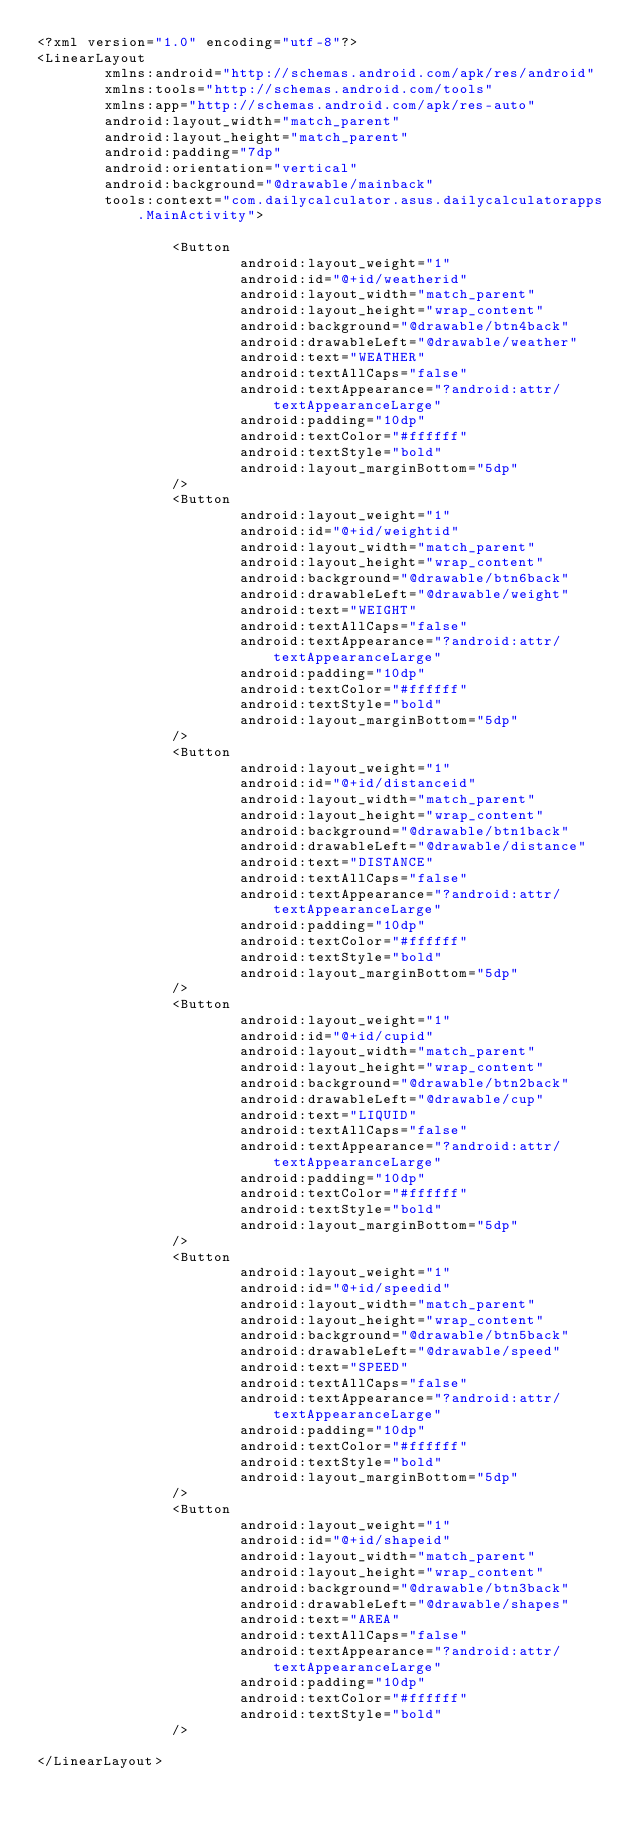<code> <loc_0><loc_0><loc_500><loc_500><_XML_><?xml version="1.0" encoding="utf-8"?>
<LinearLayout
        xmlns:android="http://schemas.android.com/apk/res/android"
        xmlns:tools="http://schemas.android.com/tools"
        xmlns:app="http://schemas.android.com/apk/res-auto"
        android:layout_width="match_parent"
        android:layout_height="match_parent"
        android:padding="7dp"
        android:orientation="vertical"
        android:background="@drawable/mainback"
        tools:context="com.dailycalculator.asus.dailycalculatorapps.MainActivity">

                <Button
                        android:layout_weight="1"
                        android:id="@+id/weatherid"
                        android:layout_width="match_parent"
                        android:layout_height="wrap_content"
                        android:background="@drawable/btn4back"
                        android:drawableLeft="@drawable/weather"
                        android:text="WEATHER"
                        android:textAllCaps="false"
                        android:textAppearance="?android:attr/textAppearanceLarge"
                        android:padding="10dp"
                        android:textColor="#ffffff"
                        android:textStyle="bold"
                        android:layout_marginBottom="5dp"
                />
                <Button
                        android:layout_weight="1"
                        android:id="@+id/weightid"
                        android:layout_width="match_parent"
                        android:layout_height="wrap_content"
                        android:background="@drawable/btn6back"
                        android:drawableLeft="@drawable/weight"
                        android:text="WEIGHT"
                        android:textAllCaps="false"
                        android:textAppearance="?android:attr/textAppearanceLarge"
                        android:padding="10dp"
                        android:textColor="#ffffff"
                        android:textStyle="bold"
                        android:layout_marginBottom="5dp"
                />
                <Button
                        android:layout_weight="1"
                        android:id="@+id/distanceid"
                        android:layout_width="match_parent"
                        android:layout_height="wrap_content"
                        android:background="@drawable/btn1back"
                        android:drawableLeft="@drawable/distance"
                        android:text="DISTANCE"
                        android:textAllCaps="false"
                        android:textAppearance="?android:attr/textAppearanceLarge"
                        android:padding="10dp"
                        android:textColor="#ffffff"
                        android:textStyle="bold"
                        android:layout_marginBottom="5dp"
                />
                <Button
                        android:layout_weight="1"
                        android:id="@+id/cupid"
                        android:layout_width="match_parent"
                        android:layout_height="wrap_content"
                        android:background="@drawable/btn2back"
                        android:drawableLeft="@drawable/cup"
                        android:text="LIQUID"
                        android:textAllCaps="false"
                        android:textAppearance="?android:attr/textAppearanceLarge"
                        android:padding="10dp"
                        android:textColor="#ffffff"
                        android:textStyle="bold"
                        android:layout_marginBottom="5dp"
                />
                <Button
                        android:layout_weight="1"
                        android:id="@+id/speedid"
                        android:layout_width="match_parent"
                        android:layout_height="wrap_content"
                        android:background="@drawable/btn5back"
                        android:drawableLeft="@drawable/speed"
                        android:text="SPEED"
                        android:textAllCaps="false"
                        android:textAppearance="?android:attr/textAppearanceLarge"
                        android:padding="10dp"
                        android:textColor="#ffffff"
                        android:textStyle="bold"
                        android:layout_marginBottom="5dp"
                />
                <Button
                        android:layout_weight="1"
                        android:id="@+id/shapeid"
                        android:layout_width="match_parent"
                        android:layout_height="wrap_content"
                        android:background="@drawable/btn3back"
                        android:drawableLeft="@drawable/shapes"
                        android:text="AREA"
                        android:textAllCaps="false"
                        android:textAppearance="?android:attr/textAppearanceLarge"
                        android:padding="10dp"
                        android:textColor="#ffffff"
                        android:textStyle="bold"
                />

</LinearLayout>
</code> 